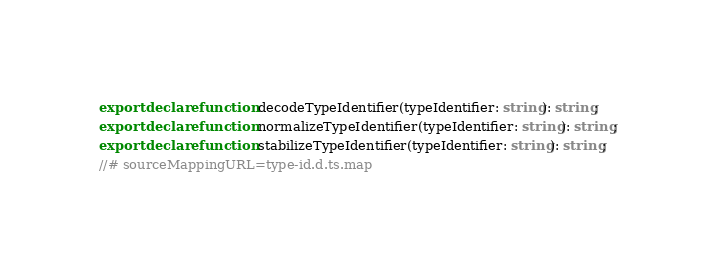<code> <loc_0><loc_0><loc_500><loc_500><_TypeScript_>export declare function decodeTypeIdentifier(typeIdentifier: string): string;
export declare function normalizeTypeIdentifier(typeIdentifier: string): string;
export declare function stabilizeTypeIdentifier(typeIdentifier: string): string;
//# sourceMappingURL=type-id.d.ts.map</code> 